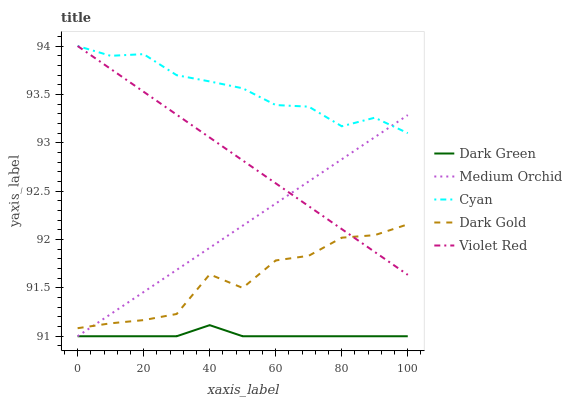Does Violet Red have the minimum area under the curve?
Answer yes or no. No. Does Violet Red have the maximum area under the curve?
Answer yes or no. No. Is Medium Orchid the smoothest?
Answer yes or no. No. Is Medium Orchid the roughest?
Answer yes or no. No. Does Violet Red have the lowest value?
Answer yes or no. No. Does Medium Orchid have the highest value?
Answer yes or no. No. Is Dark Green less than Dark Gold?
Answer yes or no. Yes. Is Cyan greater than Dark Gold?
Answer yes or no. Yes. Does Dark Green intersect Dark Gold?
Answer yes or no. No. 